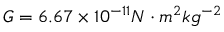<formula> <loc_0><loc_0><loc_500><loc_500>G = 6 . 6 7 \times 1 0 ^ { - 1 1 } N \cdot m ^ { 2 } k g ^ { - 2 }</formula> 